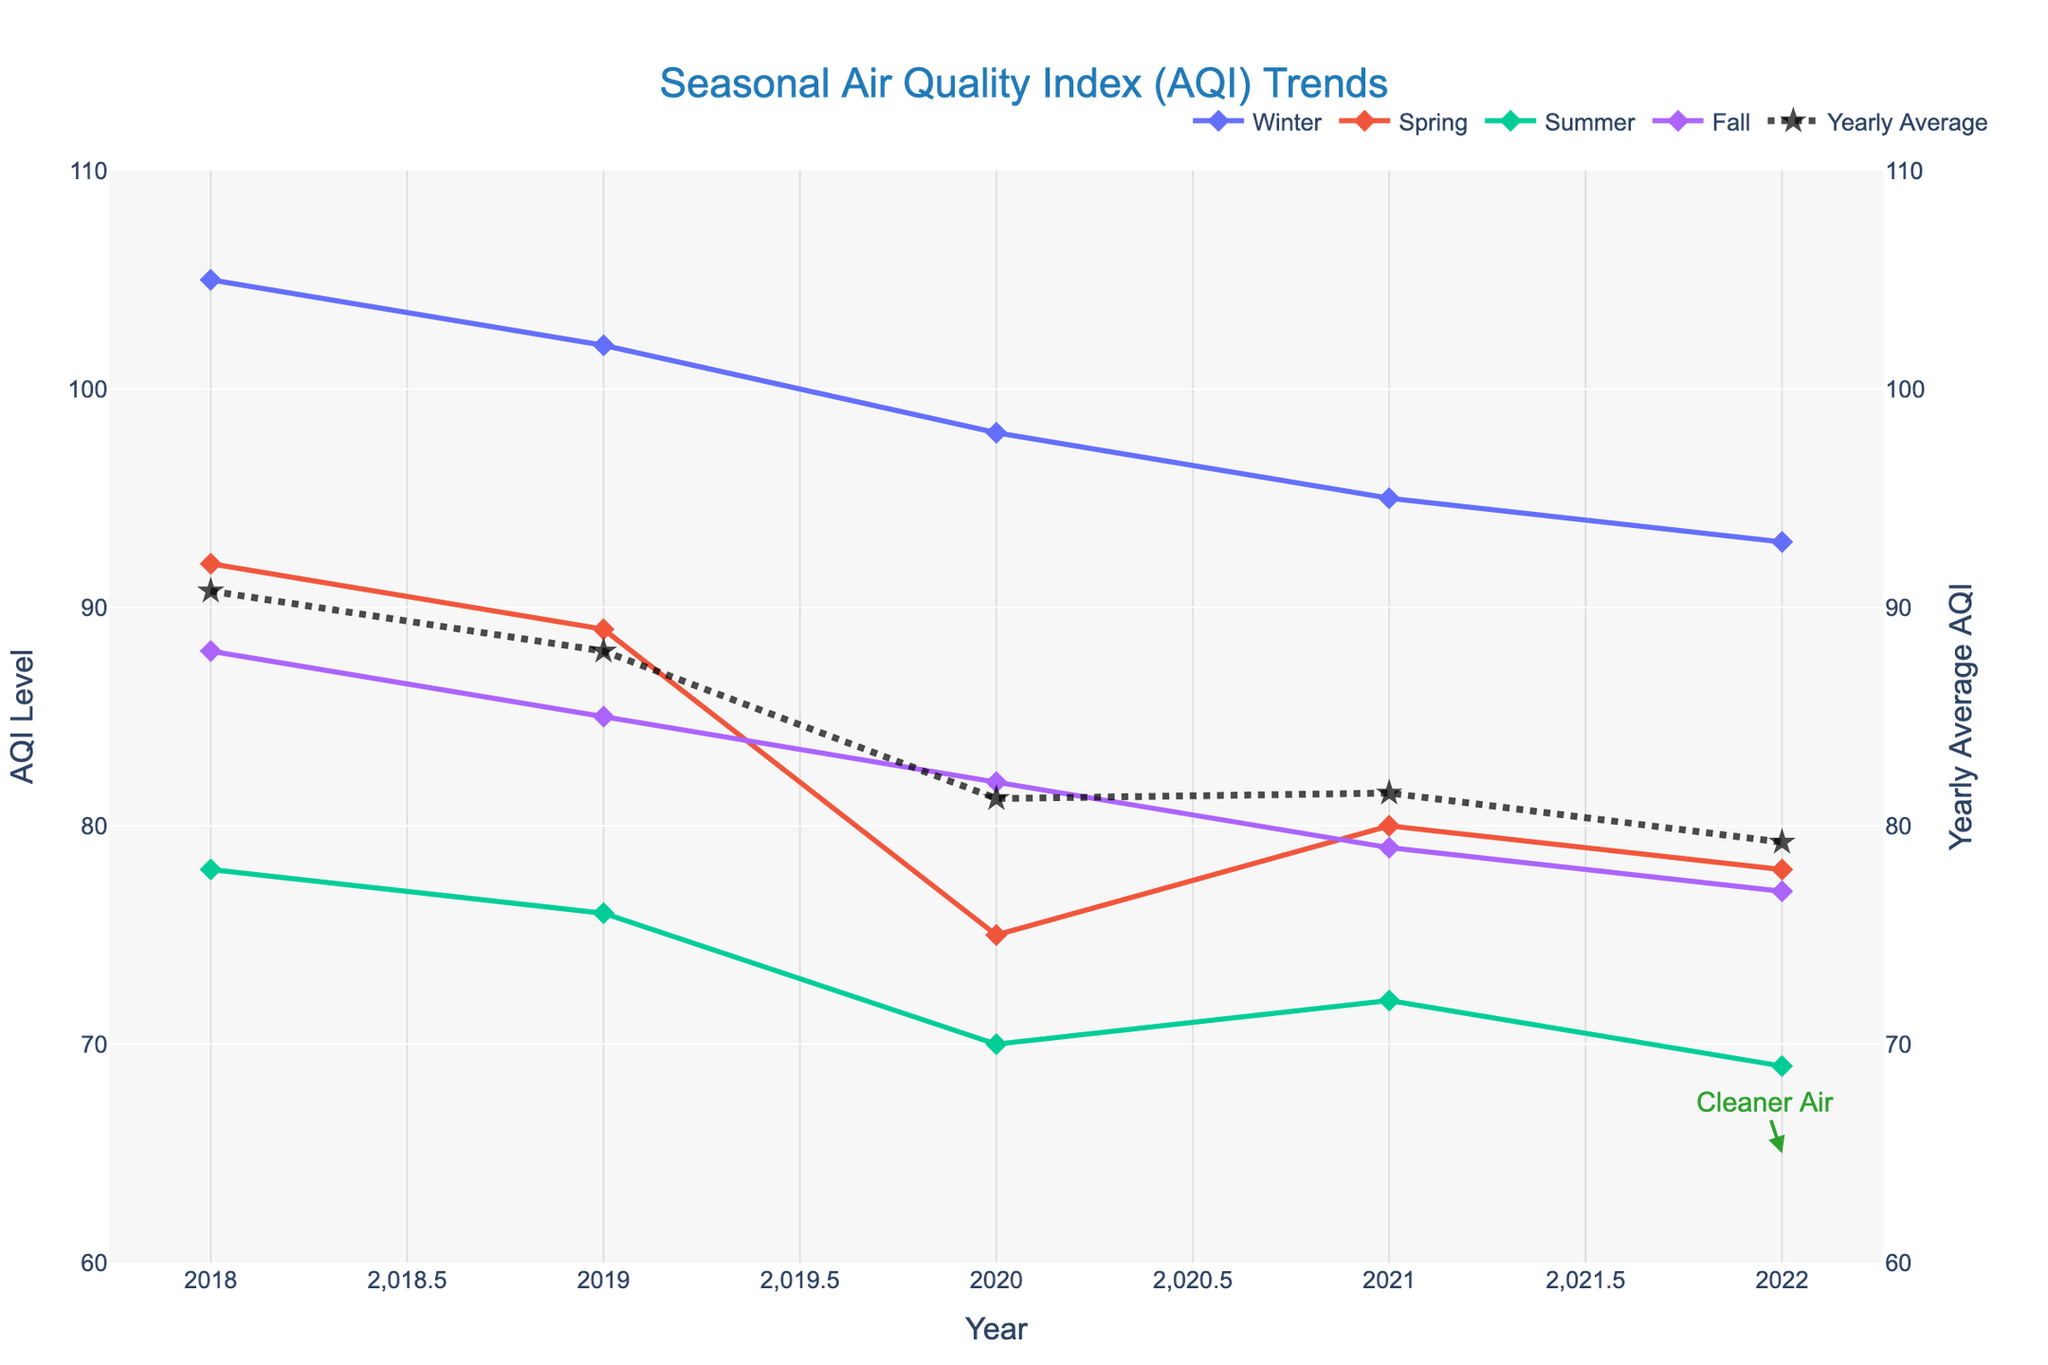What's the trend of the Yearly Average AQI over the 5-year period? Observe the "Yearly Average" line plotted as a dashed line with star markers. It shows a downward trend, starting higher in 2018 and gradually decreasing each year till 2022.
Answer: Downward Which season has the highest AQI value in 2022? Look at the 2022 marker points for each season. Winter has the highest AQI value in 2022 at 93.
Answer: Winter Identify the season with the most significant improvement in AQI from 2018 to 2022. Check the AQI values for each season in 2018 and compare them with 2022. Summer had the most significant improvement, decreasing from 78 in 2018 to 69 in 2022.
Answer: Summer Compare the AQI levels of Winter and Summer in 2021. Which one is higher? Look at the 2021 data points for Winter and Summer. Winter has an AQI of 95, and Summer has an AQI of 72. Winter is higher.
Answer: Winter Which year showed the lowest Spring AQI value? Refer to the data points for Spring across the years. The lowest AQI value in Spring was in 2020, with an AQI of 75.
Answer: 2020 What is the difference between the highest and lowest AQI values recorded in Fall over the 5 years? The highest Fall AQI is 88 in 2018; the lowest is 77 in 2022. The difference is 88 - 77.
Answer: 11 Is the 2022 'Yearly Average' AQI higher or lower than the 2018 'Yearly Average' AQI? Compare the Yearly Average AQI points for 2018 and 2022. The 2022 Yearly Average is lower than the 2018 Yearly Average.
Answer: Lower Compare the AQI levels in Spring and Fall of 2019. Which one is lower? Look at the AQI values for Spring and Fall in 2019. Spring has an AQI of 89, while Fall has an AQI of 85. Fall is lower.
Answer: Fall 